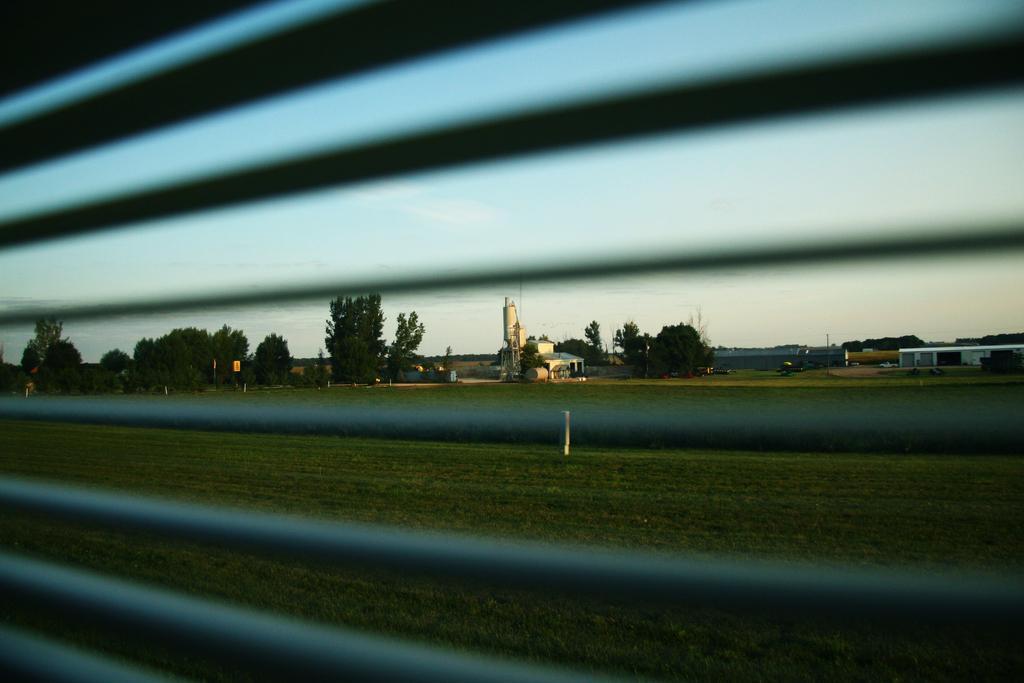In one or two sentences, can you explain what this image depicts? This picture is taken from the vehicle in which I can see the window, some grass, few trees, few buildings and the sky in the background. 